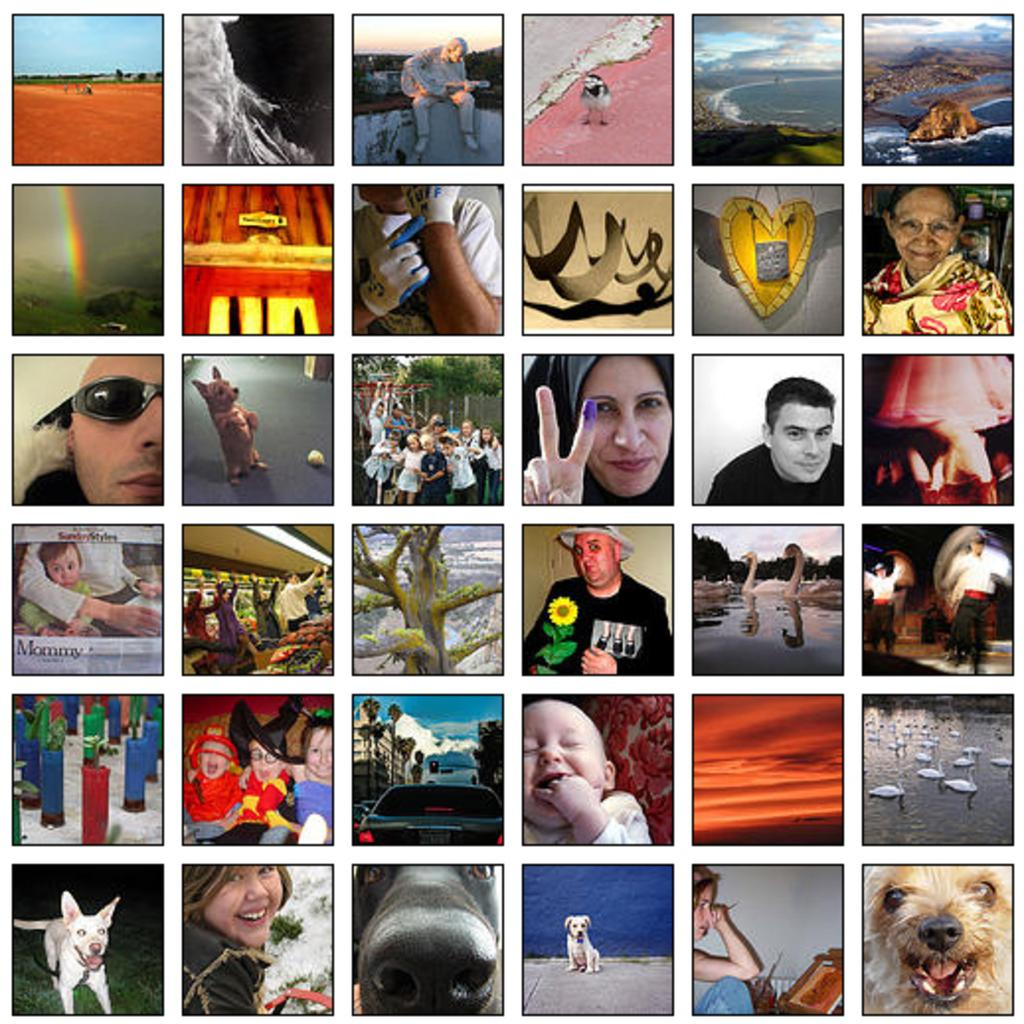What type of artwork is shown in the image? The image is a collage. What can be observed within the collage? The collage contains different pictures. How many rifles are visible in the collage? There are no rifles present in the collage; it contains different pictures. How many women are depicted in the collage? The number of women in the collage cannot be determined from the provided facts, as the collage contains different pictures. What type of cheese is shown in the collage? There is no cheese present in the collage; it contains different pictures. 